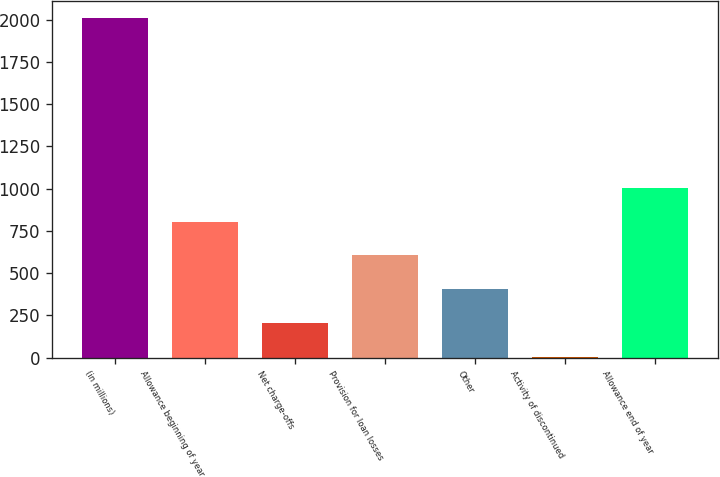<chart> <loc_0><loc_0><loc_500><loc_500><bar_chart><fcel>(in millions)<fcel>Allowance beginning of year<fcel>Net charge-offs<fcel>Provision for loan losses<fcel>Other<fcel>Activity of discontinued<fcel>Allowance end of year<nl><fcel>2008<fcel>805<fcel>203.5<fcel>604.5<fcel>404<fcel>3<fcel>1005.5<nl></chart> 